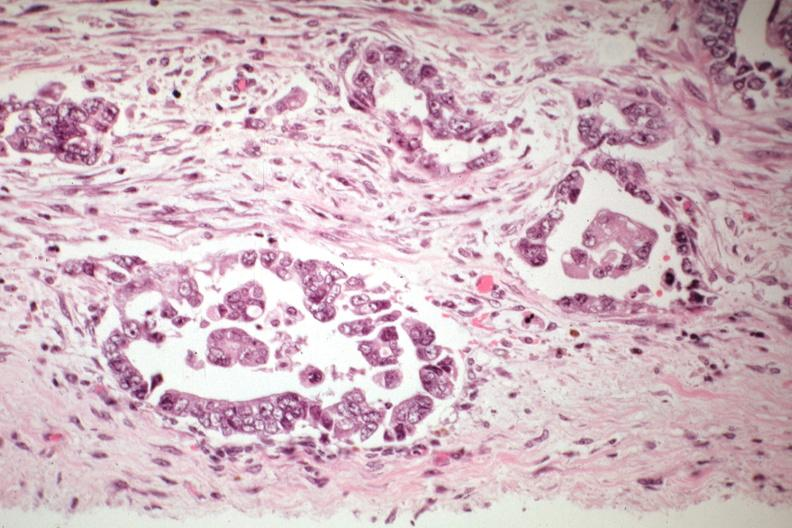what is present?
Answer the question using a single word or phrase. Female reproductive 